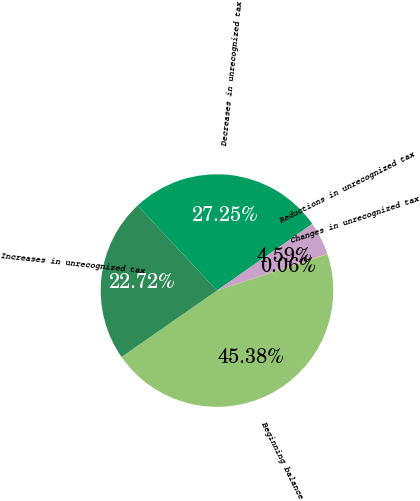<chart> <loc_0><loc_0><loc_500><loc_500><pie_chart><fcel>Beginning balance<fcel>Increases in unrecognized tax<fcel>Decreases in unrecognized tax<fcel>Reductions in unrecognized tax<fcel>Changes in unrecognized tax<nl><fcel>45.38%<fcel>22.72%<fcel>27.25%<fcel>4.59%<fcel>0.06%<nl></chart> 